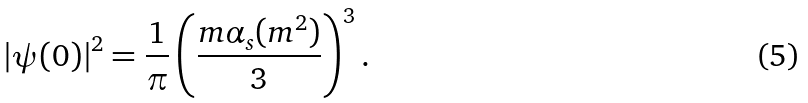Convert formula to latex. <formula><loc_0><loc_0><loc_500><loc_500>\left | \psi ( 0 ) \right | ^ { 2 } = \frac { 1 } { \pi } \left ( \frac { m \alpha _ { s } ( m ^ { 2 } ) } { 3 } \right ) ^ { 3 } .</formula> 